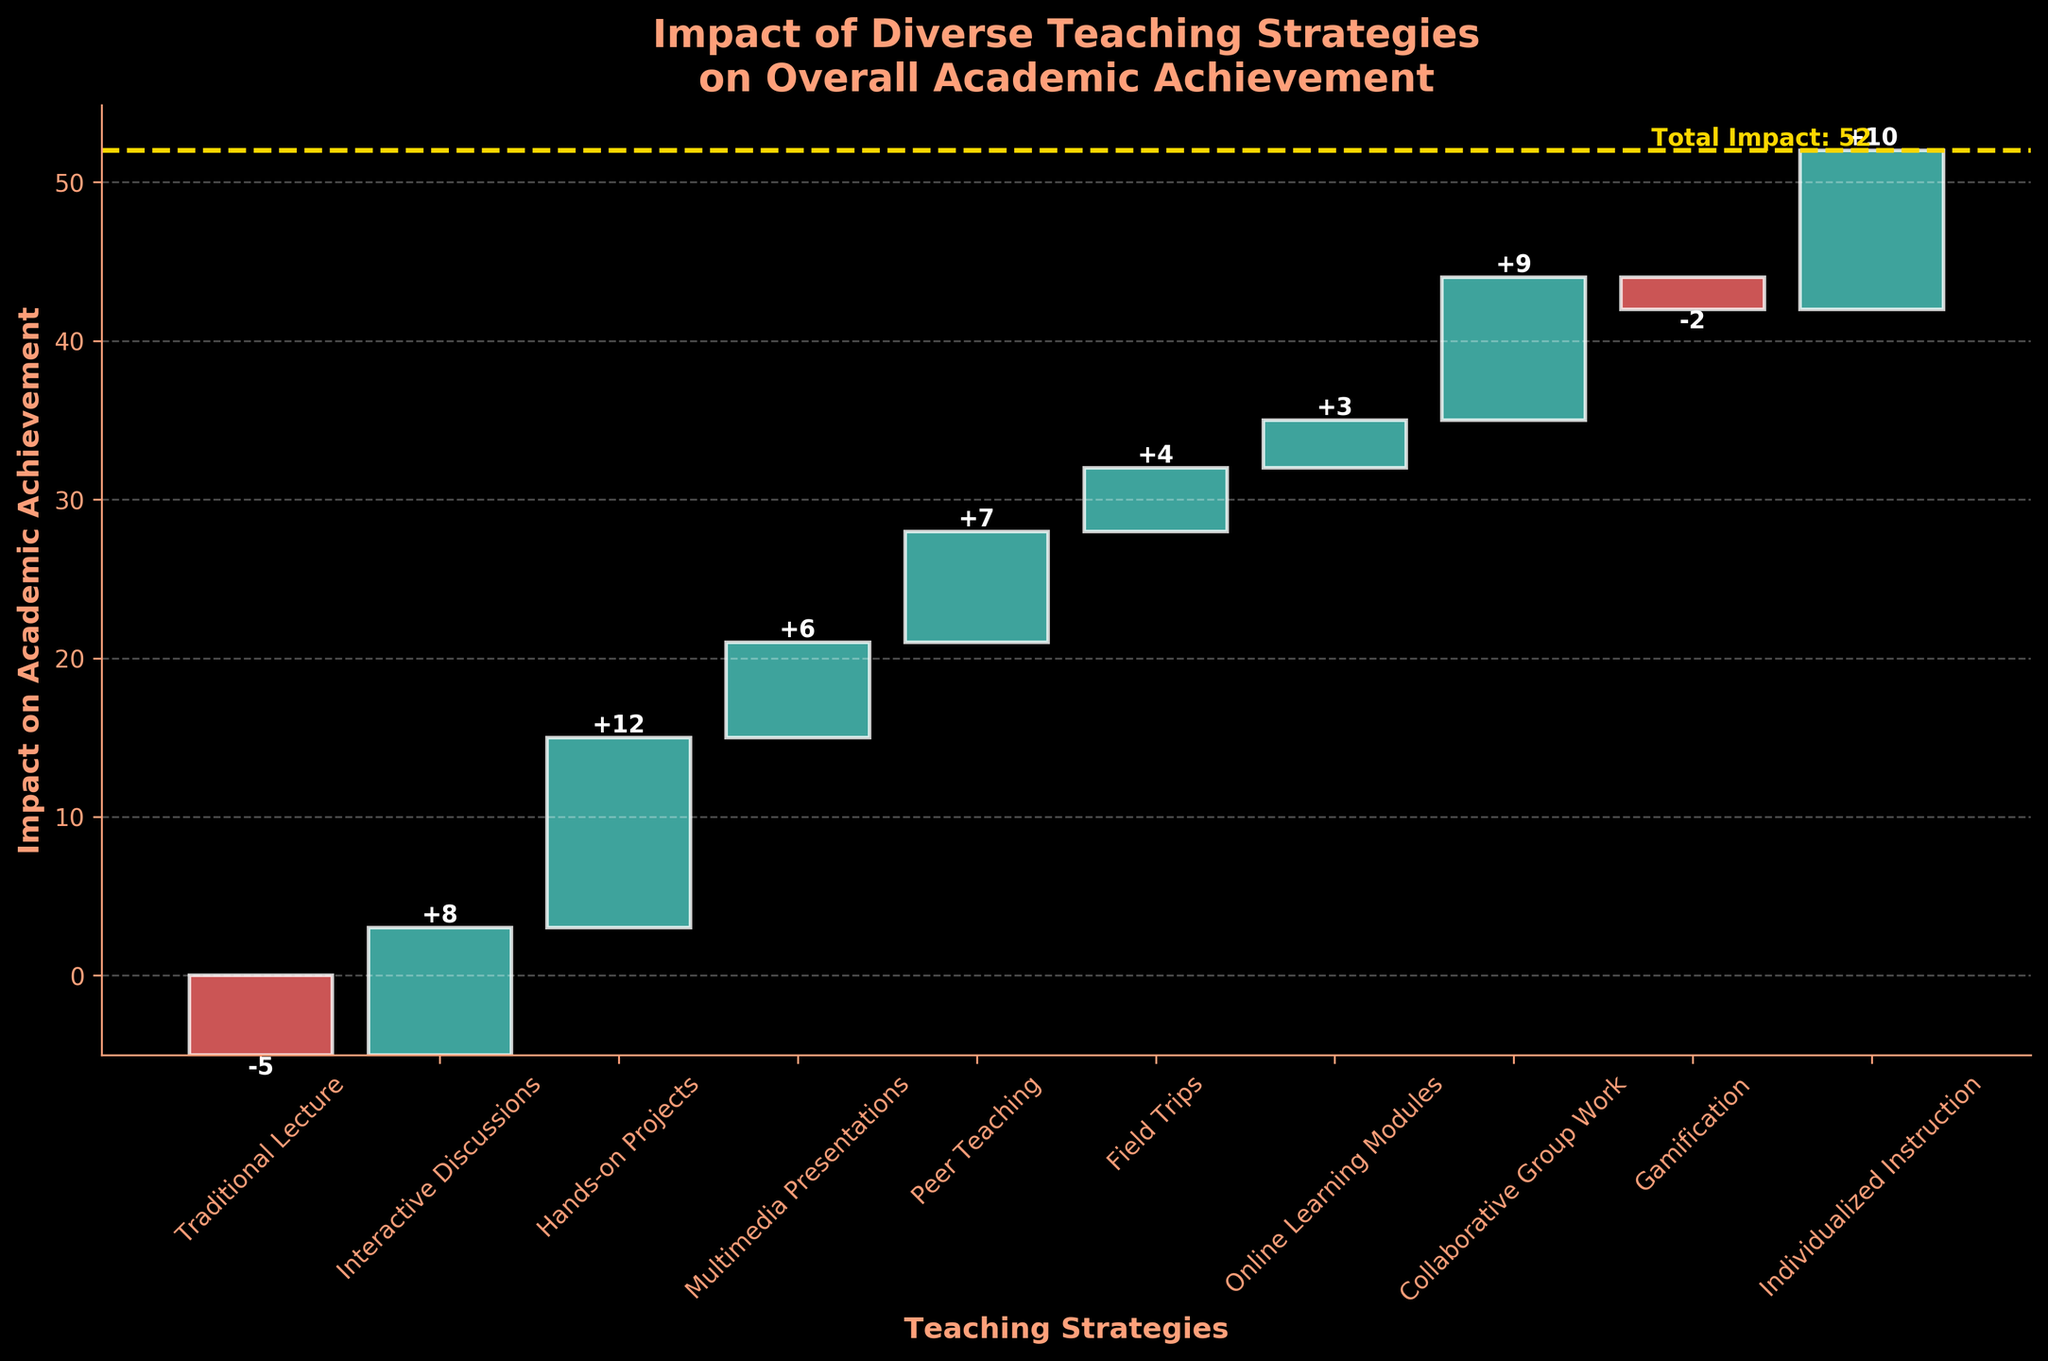What is the title of the chart? The title is displayed prominently at the top of the chart in bold and larger font size. It reads 'Impact of Diverse Teaching Strategies on Overall Academic Achievement'.
Answer: 'Impact of Diverse Teaching Strategies on Overall Academic Achievement' Which teaching strategy has the highest positive impact? By looking at the height of the bars and the annotations, we can see that 'Hands-on Projects' has the highest positive impact value of 12.
Answer: 'Hands-on Projects' How many teaching strategies have a negative impact on academic achievement? By identifying bars with negative values (displayed in red color), we can see that two strategies—'Traditional Lecture' and 'Gamification'—have negative impacts.
Answer: 2 What is the cumulative impact after 'Collaborative Group Work'? The cumulative impact after each category can be found by summing the impacts sequentially up to that point. Starting from -5 and adding subsequent values, cumulative impact after 'Collaborative Group Work' (which is the last green bar before the total line) is 42.
Answer: 42 Which category contributes the least positive impact, and what is its value? Identifying the bars with positive impacts and comparing their values, 'Online Learning Modules' contribute the least positive impact of 3.
Answer: 'Online Learning Modules' with an impact of 3 What is the total impact on academic achievement? The total impact is highlighted by the horizontal yellow line at the end of the chart; it also shows the cumulative sum of all impacts which is 52.
Answer: 52 Compare the impacts of 'Peer Teaching' and 'Individualized Instruction'. Which one has a higher impact? Observing the heights and annotations of the bars, 'Individualized Instruction' has an impact of 10, which is higher than 'Peer Teaching' with an impact of 7.
Answer: 'Individualized Instruction' What are the first and last categories in the cumulative order on the x-axis? From left to right on the x-axis, the first category is 'Traditional Lecture' and the last category is 'Individualized Instruction'.
Answer: 'Traditional Lecture' and 'Individualized Instruction' By how much does 'Interactive Discussions' improve over 'Traditional Lecture' in terms of impact? The impact of 'Interactive Discussions' is 8 and the impact of 'Traditional Lecture' is -5. Therefore, the improvement is 8 - (-5) = 13.
Answer: 13 What is the combined impact of 'Field Trips' and 'Gamification' on academic achievement? Adding the impacts of 'Field Trips' (4) and 'Gamification' (-2), the combined impact is 4 + (-2) = 2.
Answer: 2 